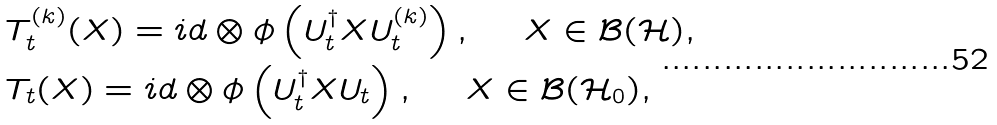<formula> <loc_0><loc_0><loc_500><loc_500>& T _ { t } ^ { ( k ) } ( X ) = i d \otimes \phi \left ( U ^ { \dag } _ { t } X U ^ { ( k ) } _ { t } \right ) , \ \quad X \in \mathcal { B } ( \mathcal { H } ) , \\ & T _ { t } ( X ) = i d \otimes \phi \left ( U ^ { \dag } _ { t } X U _ { t } \right ) , \ \quad X \in \mathcal { B } ( \mathcal { H } _ { 0 } ) ,</formula> 